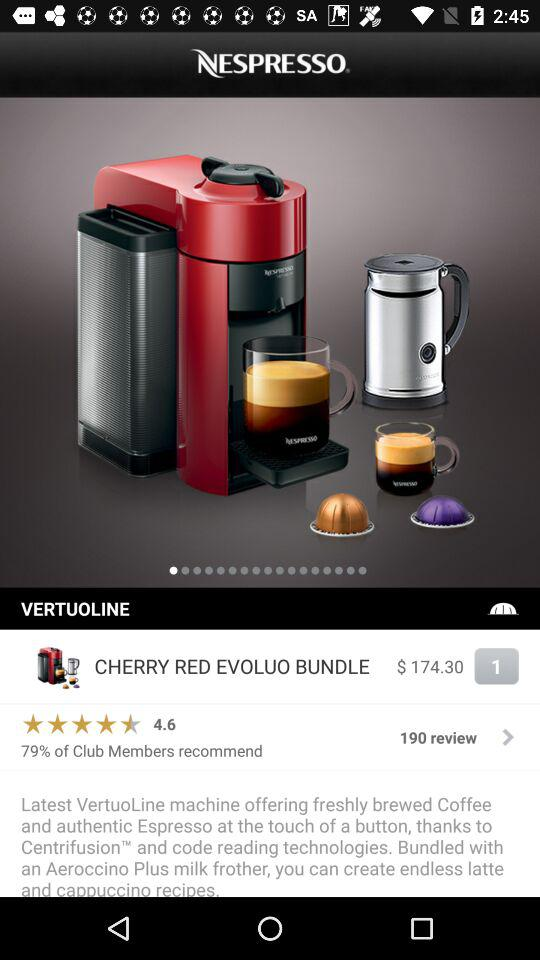What percentage of club members recommend the product? There are 79% of club members recommended. 